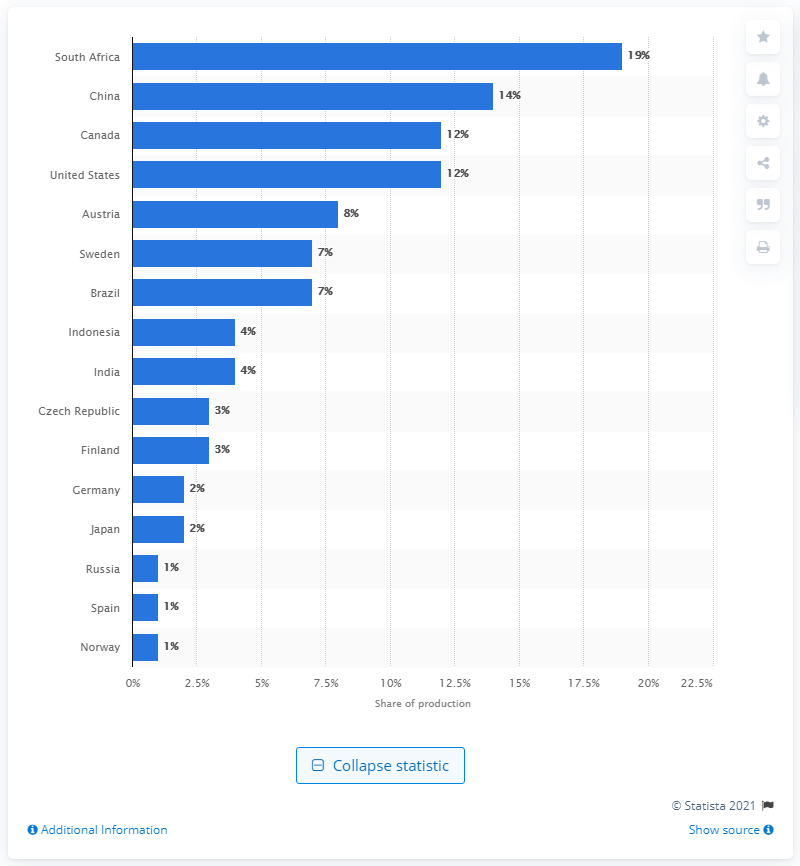Indicate a few pertinent items in this graphic. In 2014, South Africa produced approximately 19% of the world's viscose dissolving pulp. 